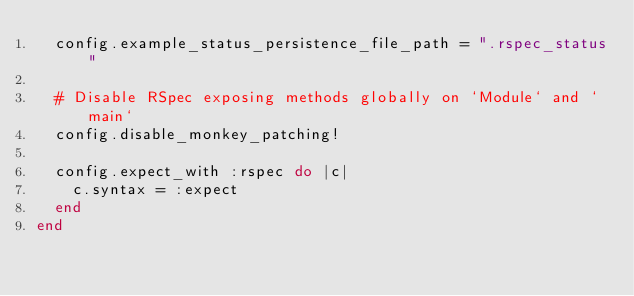Convert code to text. <code><loc_0><loc_0><loc_500><loc_500><_Ruby_>  config.example_status_persistence_file_path = ".rspec_status"

  # Disable RSpec exposing methods globally on `Module` and `main`
  config.disable_monkey_patching!

  config.expect_with :rspec do |c|
    c.syntax = :expect
  end
end
</code> 